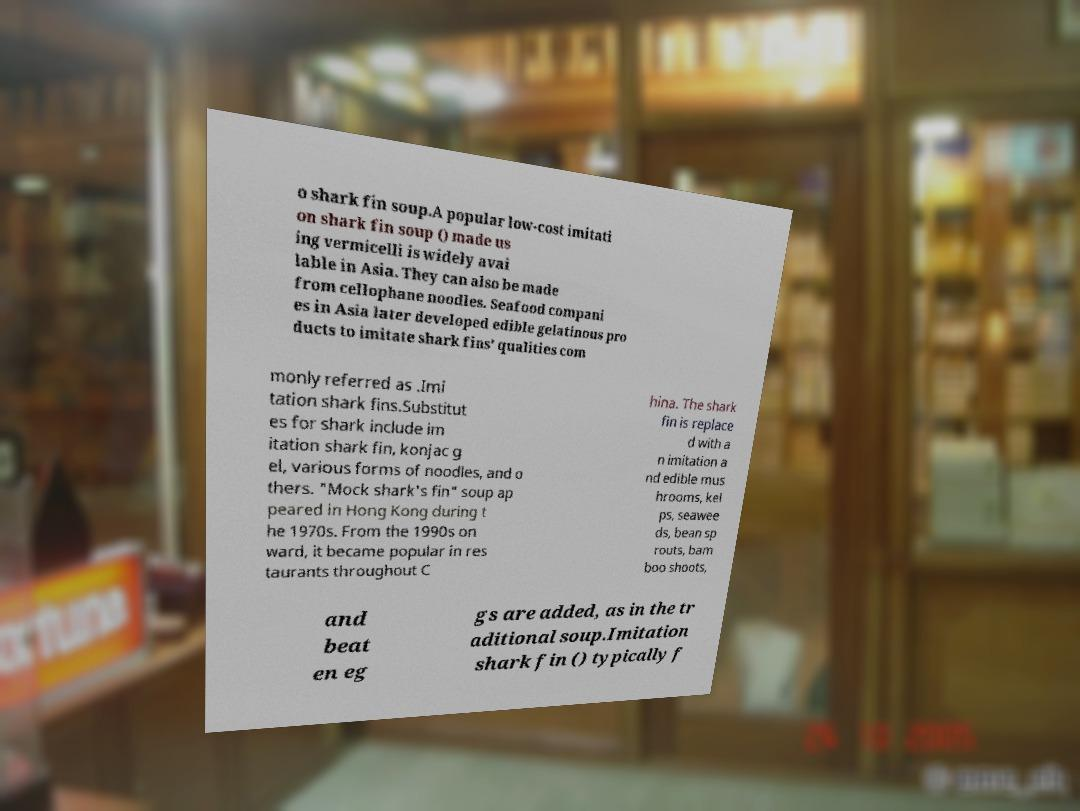Can you accurately transcribe the text from the provided image for me? o shark fin soup.A popular low-cost imitati on shark fin soup () made us ing vermicelli is widely avai lable in Asia. They can also be made from cellophane noodles. Seafood compani es in Asia later developed edible gelatinous pro ducts to imitate shark fins' qualities com monly referred as .Imi tation shark fins.Substitut es for shark include im itation shark fin, konjac g el, various forms of noodles, and o thers. "Mock shark's fin" soup ap peared in Hong Kong during t he 1970s. From the 1990s on ward, it became popular in res taurants throughout C hina. The shark fin is replace d with a n imitation a nd edible mus hrooms, kel ps, seawee ds, bean sp routs, bam boo shoots, and beat en eg gs are added, as in the tr aditional soup.Imitation shark fin () typically f 